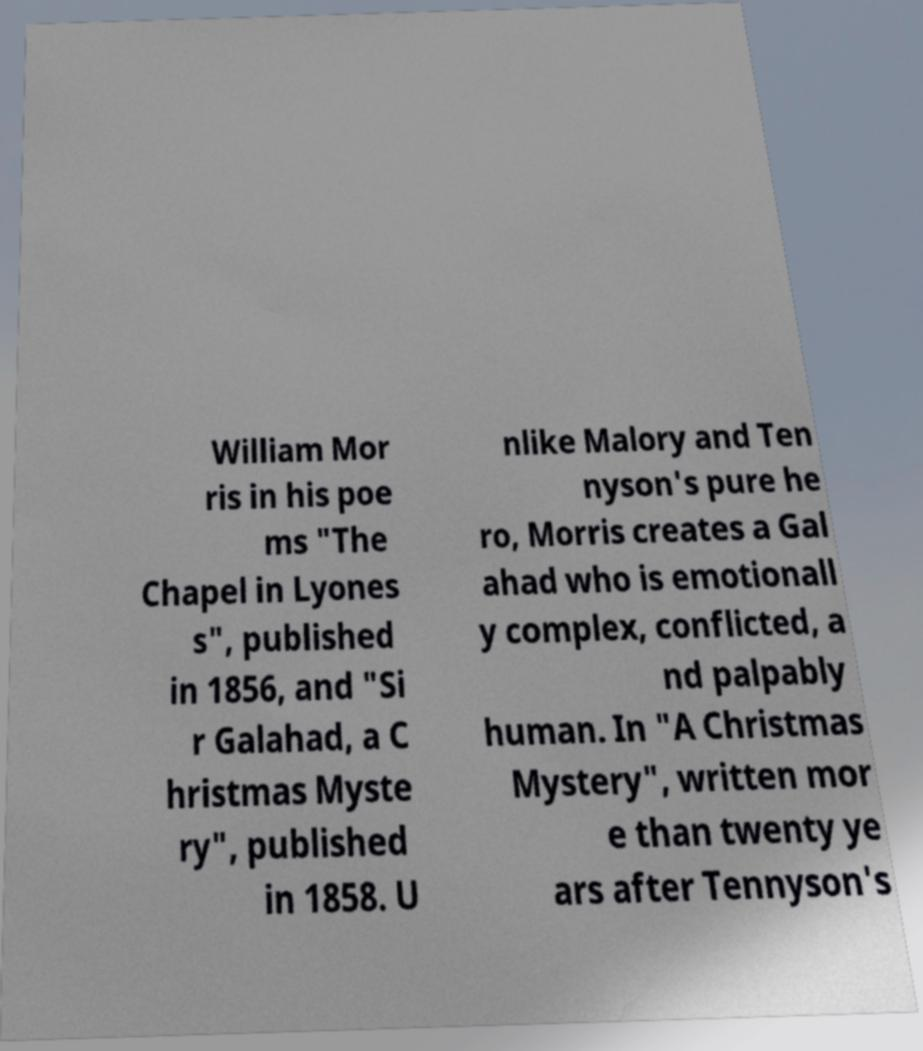Can you accurately transcribe the text from the provided image for me? William Mor ris in his poe ms "The Chapel in Lyones s", published in 1856, and "Si r Galahad, a C hristmas Myste ry", published in 1858. U nlike Malory and Ten nyson's pure he ro, Morris creates a Gal ahad who is emotionall y complex, conflicted, a nd palpably human. In "A Christmas Mystery", written mor e than twenty ye ars after Tennyson's 